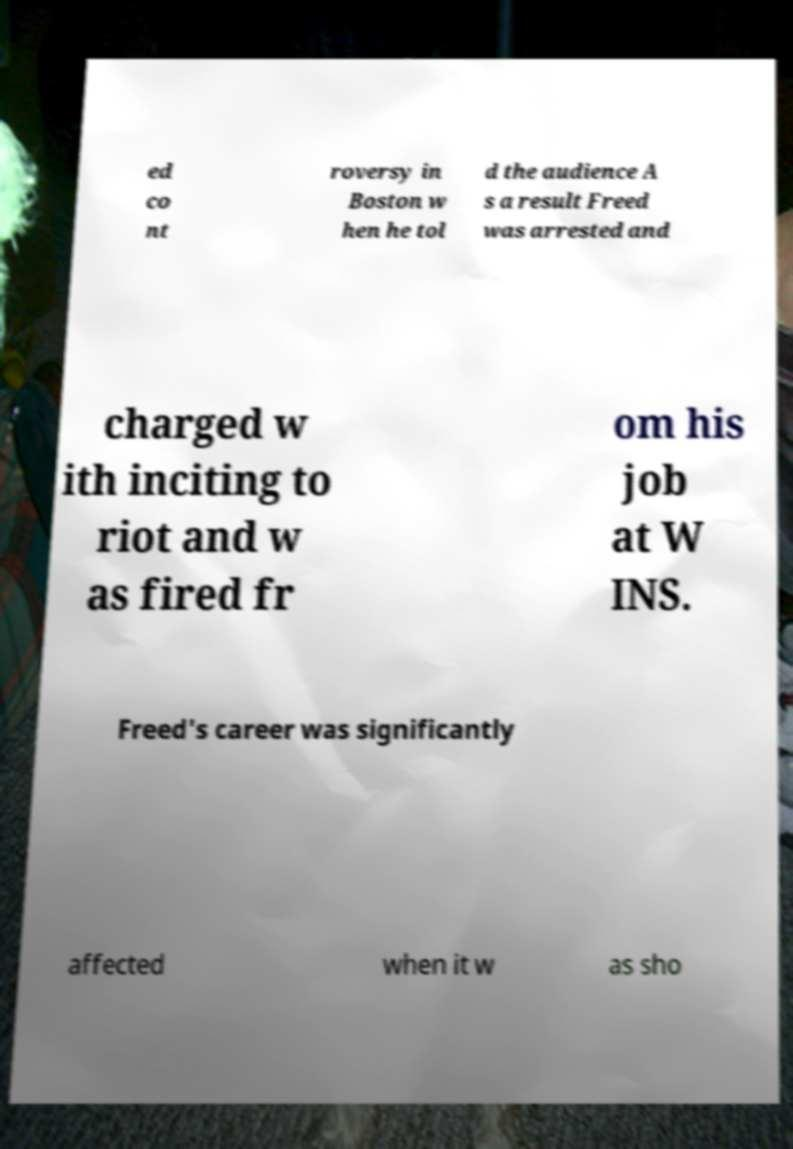What messages or text are displayed in this image? I need them in a readable, typed format. ed co nt roversy in Boston w hen he tol d the audience A s a result Freed was arrested and charged w ith inciting to riot and w as fired fr om his job at W INS. Freed's career was significantly affected when it w as sho 